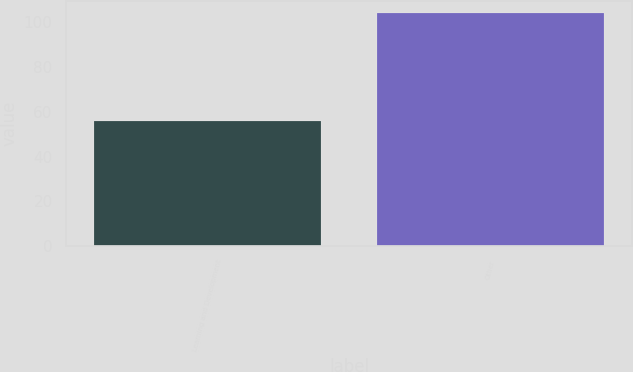Convert chart to OTSL. <chart><loc_0><loc_0><loc_500><loc_500><bar_chart><fcel>Learning and Development<fcel>Other<nl><fcel>56<fcel>104.2<nl></chart> 